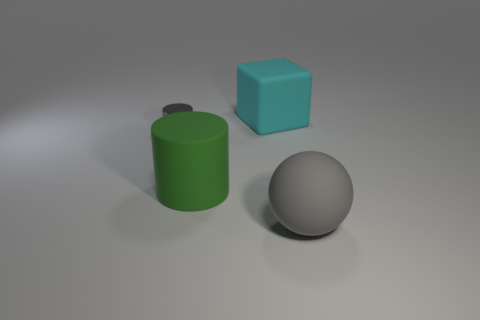Add 1 large cyan rubber things. How many objects exist? 5 Subtract all cubes. How many objects are left? 3 Subtract all gray cylinders. Subtract all cyan blocks. How many cylinders are left? 1 Subtract all gray metallic objects. Subtract all big yellow cubes. How many objects are left? 3 Add 2 small things. How many small things are left? 3 Add 1 big green things. How many big green things exist? 2 Subtract 0 yellow spheres. How many objects are left? 4 